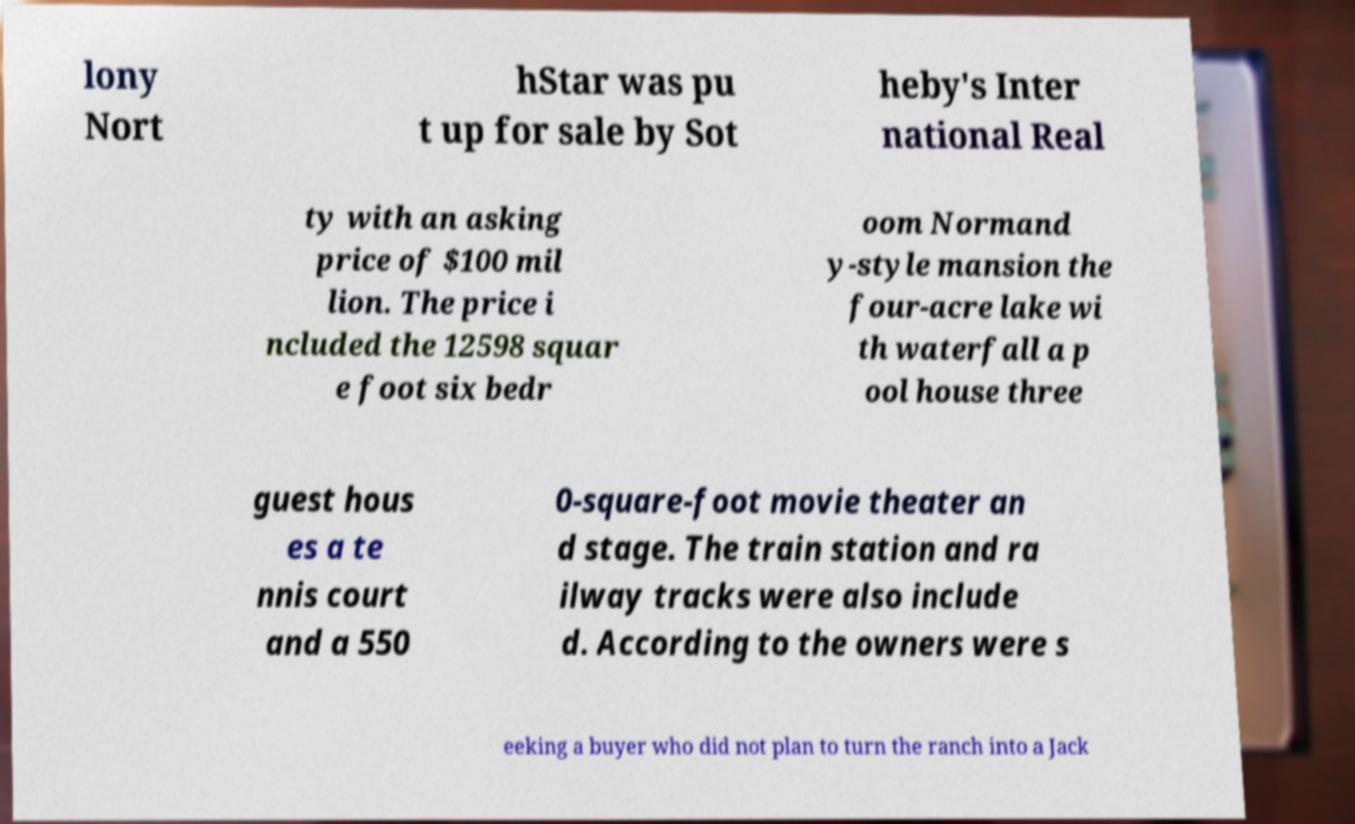Please read and relay the text visible in this image. What does it say? lony Nort hStar was pu t up for sale by Sot heby's Inter national Real ty with an asking price of $100 mil lion. The price i ncluded the 12598 squar e foot six bedr oom Normand y-style mansion the four-acre lake wi th waterfall a p ool house three guest hous es a te nnis court and a 550 0-square-foot movie theater an d stage. The train station and ra ilway tracks were also include d. According to the owners were s eeking a buyer who did not plan to turn the ranch into a Jack 